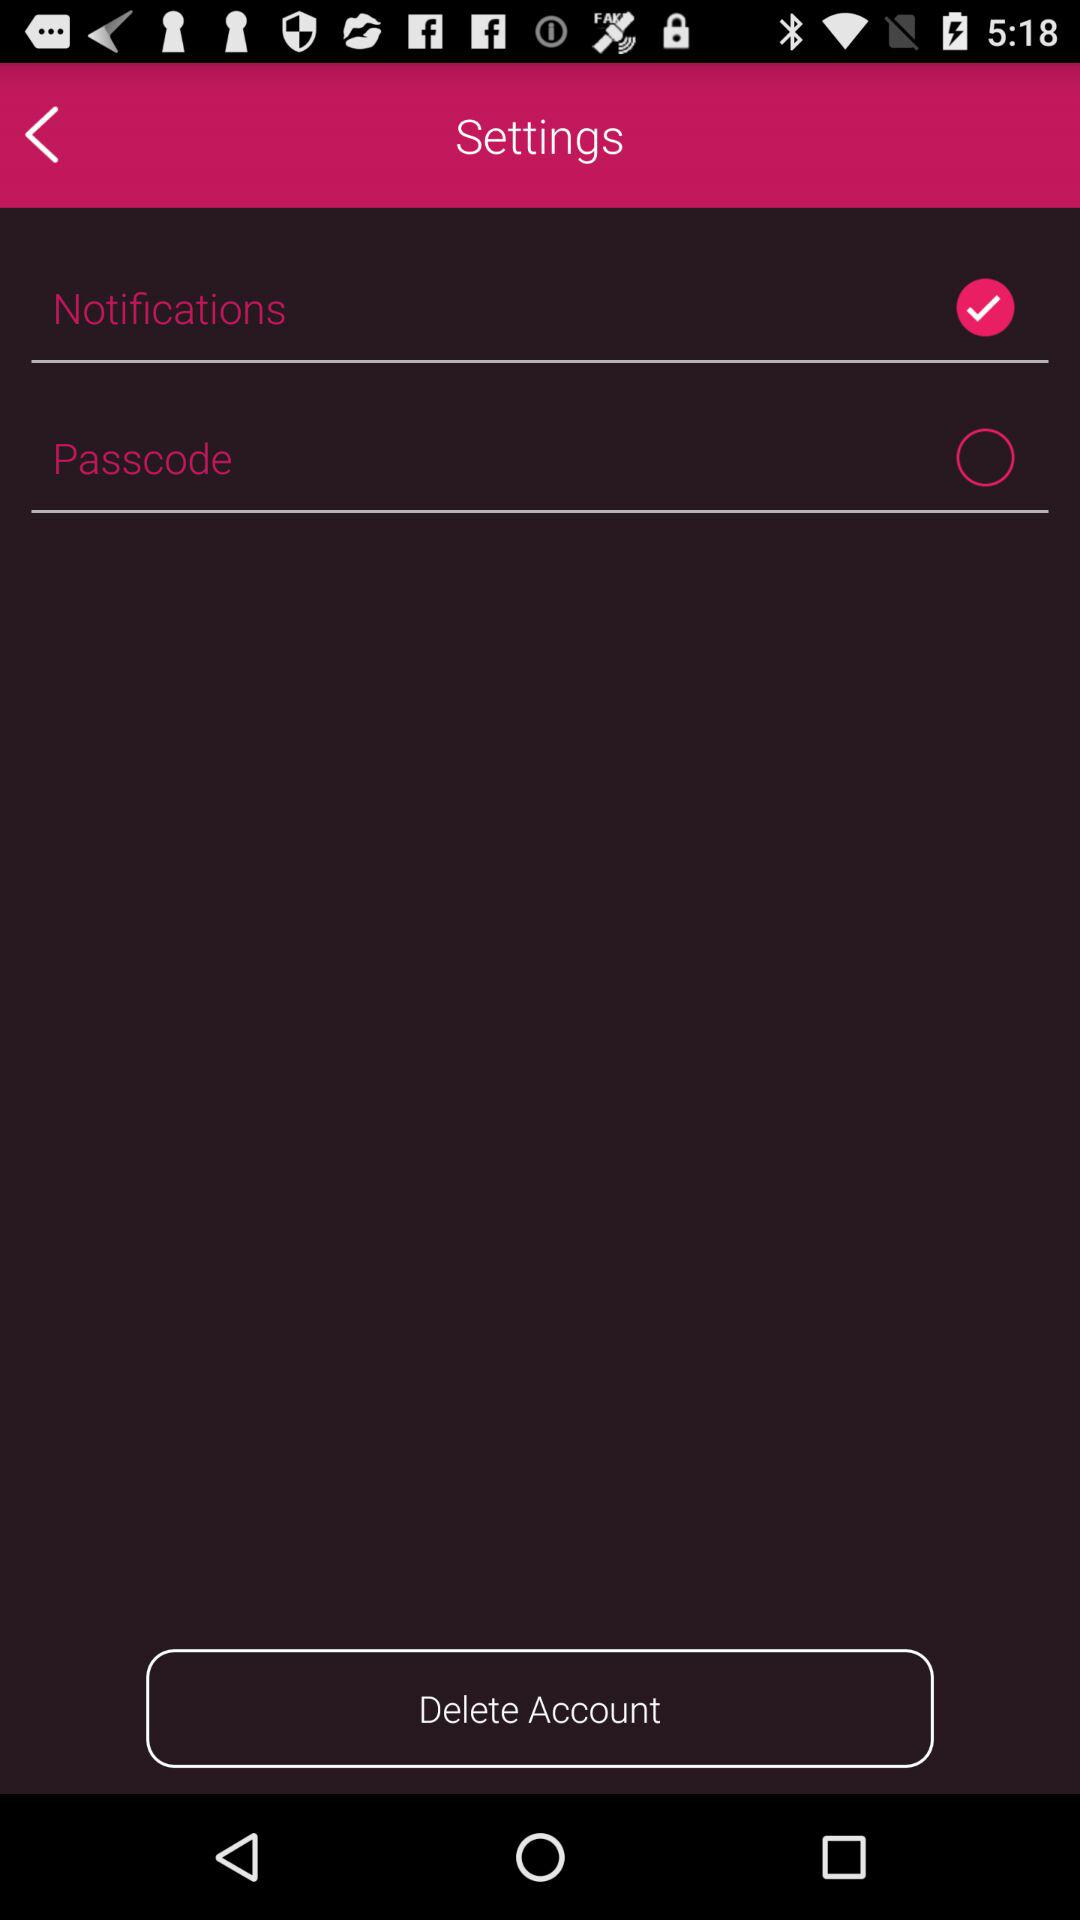What is the status of the "Passcode"? The status is "off". 